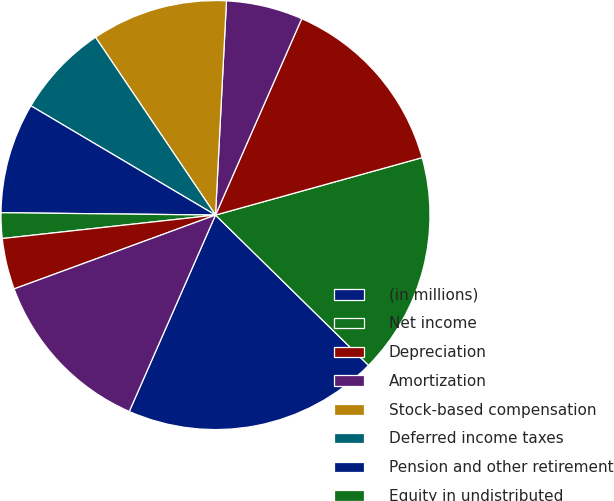Convert chart to OTSL. <chart><loc_0><loc_0><loc_500><loc_500><pie_chart><fcel>(in millions)<fcel>Net income<fcel>Depreciation<fcel>Amortization<fcel>Stock-based compensation<fcel>Deferred income taxes<fcel>Pension and other retirement<fcel>Equity in undistributed<fcel>Decrease (increase) in<fcel>Increase in inventories<nl><fcel>19.23%<fcel>16.67%<fcel>14.1%<fcel>5.77%<fcel>10.26%<fcel>7.05%<fcel>8.33%<fcel>1.92%<fcel>3.85%<fcel>12.82%<nl></chart> 